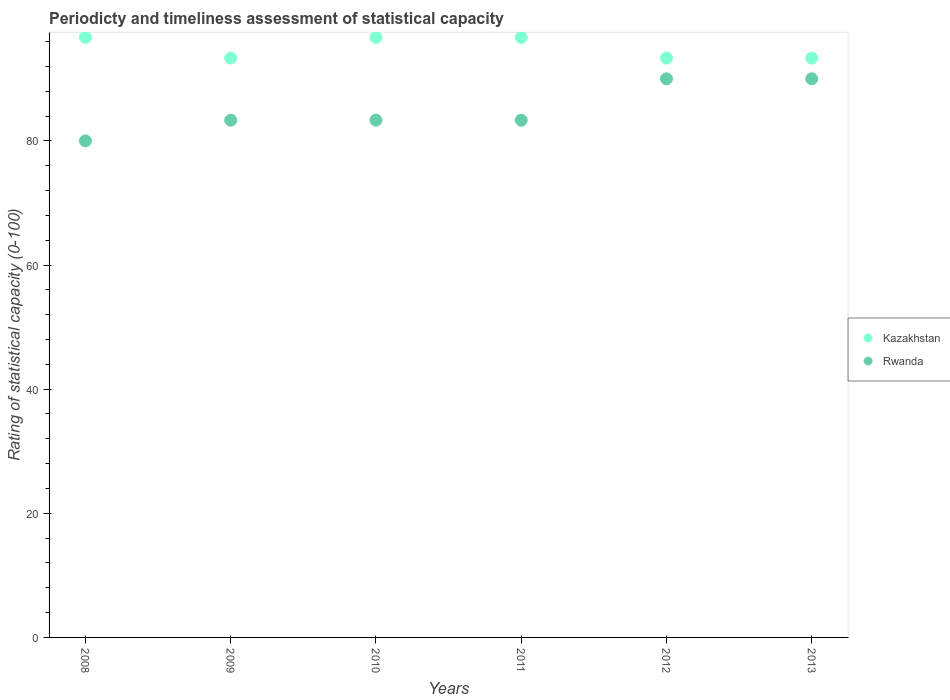What is the rating of statistical capacity in Kazakhstan in 2012?
Your response must be concise. 93.33. Across all years, what is the maximum rating of statistical capacity in Rwanda?
Your answer should be very brief. 90. Across all years, what is the minimum rating of statistical capacity in Rwanda?
Give a very brief answer. 80. In which year was the rating of statistical capacity in Kazakhstan maximum?
Your answer should be very brief. 2008. In which year was the rating of statistical capacity in Kazakhstan minimum?
Give a very brief answer. 2009. What is the total rating of statistical capacity in Rwanda in the graph?
Give a very brief answer. 510. What is the difference between the rating of statistical capacity in Kazakhstan in 2010 and that in 2011?
Provide a short and direct response. 0. What is the difference between the rating of statistical capacity in Kazakhstan in 2013 and the rating of statistical capacity in Rwanda in 2009?
Provide a succinct answer. 10. What is the average rating of statistical capacity in Kazakhstan per year?
Provide a succinct answer. 95. In the year 2010, what is the difference between the rating of statistical capacity in Kazakhstan and rating of statistical capacity in Rwanda?
Provide a short and direct response. 13.33. Is the rating of statistical capacity in Rwanda in 2010 less than that in 2013?
Give a very brief answer. Yes. Is the difference between the rating of statistical capacity in Kazakhstan in 2008 and 2010 greater than the difference between the rating of statistical capacity in Rwanda in 2008 and 2010?
Keep it short and to the point. Yes. What is the difference between the highest and the second highest rating of statistical capacity in Rwanda?
Your answer should be very brief. 0. What is the difference between the highest and the lowest rating of statistical capacity in Kazakhstan?
Offer a very short reply. 3.33. What is the difference between two consecutive major ticks on the Y-axis?
Your response must be concise. 20. Are the values on the major ticks of Y-axis written in scientific E-notation?
Your answer should be compact. No. Does the graph contain any zero values?
Give a very brief answer. No. How are the legend labels stacked?
Provide a succinct answer. Vertical. What is the title of the graph?
Your response must be concise. Periodicty and timeliness assessment of statistical capacity. Does "Poland" appear as one of the legend labels in the graph?
Keep it short and to the point. No. What is the label or title of the X-axis?
Provide a succinct answer. Years. What is the label or title of the Y-axis?
Keep it short and to the point. Rating of statistical capacity (0-100). What is the Rating of statistical capacity (0-100) in Kazakhstan in 2008?
Offer a very short reply. 96.67. What is the Rating of statistical capacity (0-100) of Rwanda in 2008?
Make the answer very short. 80. What is the Rating of statistical capacity (0-100) in Kazakhstan in 2009?
Your answer should be very brief. 93.33. What is the Rating of statistical capacity (0-100) in Rwanda in 2009?
Your response must be concise. 83.33. What is the Rating of statistical capacity (0-100) of Kazakhstan in 2010?
Offer a terse response. 96.67. What is the Rating of statistical capacity (0-100) of Rwanda in 2010?
Provide a short and direct response. 83.33. What is the Rating of statistical capacity (0-100) of Kazakhstan in 2011?
Offer a very short reply. 96.67. What is the Rating of statistical capacity (0-100) in Rwanda in 2011?
Keep it short and to the point. 83.33. What is the Rating of statistical capacity (0-100) of Kazakhstan in 2012?
Provide a short and direct response. 93.33. What is the Rating of statistical capacity (0-100) of Rwanda in 2012?
Give a very brief answer. 90. What is the Rating of statistical capacity (0-100) in Kazakhstan in 2013?
Keep it short and to the point. 93.33. What is the Rating of statistical capacity (0-100) of Rwanda in 2013?
Your response must be concise. 90. Across all years, what is the maximum Rating of statistical capacity (0-100) of Kazakhstan?
Ensure brevity in your answer.  96.67. Across all years, what is the minimum Rating of statistical capacity (0-100) of Kazakhstan?
Offer a terse response. 93.33. Across all years, what is the minimum Rating of statistical capacity (0-100) in Rwanda?
Your answer should be very brief. 80. What is the total Rating of statistical capacity (0-100) of Kazakhstan in the graph?
Ensure brevity in your answer.  570. What is the total Rating of statistical capacity (0-100) in Rwanda in the graph?
Make the answer very short. 510. What is the difference between the Rating of statistical capacity (0-100) of Kazakhstan in 2008 and that in 2010?
Ensure brevity in your answer.  0. What is the difference between the Rating of statistical capacity (0-100) in Rwanda in 2008 and that in 2010?
Keep it short and to the point. -3.33. What is the difference between the Rating of statistical capacity (0-100) of Kazakhstan in 2008 and that in 2011?
Keep it short and to the point. 0. What is the difference between the Rating of statistical capacity (0-100) in Rwanda in 2008 and that in 2011?
Give a very brief answer. -3.33. What is the difference between the Rating of statistical capacity (0-100) in Kazakhstan in 2008 and that in 2012?
Make the answer very short. 3.33. What is the difference between the Rating of statistical capacity (0-100) of Rwanda in 2008 and that in 2012?
Your answer should be compact. -10. What is the difference between the Rating of statistical capacity (0-100) of Rwanda in 2008 and that in 2013?
Keep it short and to the point. -10. What is the difference between the Rating of statistical capacity (0-100) of Kazakhstan in 2009 and that in 2010?
Keep it short and to the point. -3.33. What is the difference between the Rating of statistical capacity (0-100) of Rwanda in 2009 and that in 2012?
Offer a very short reply. -6.67. What is the difference between the Rating of statistical capacity (0-100) in Rwanda in 2009 and that in 2013?
Provide a succinct answer. -6.67. What is the difference between the Rating of statistical capacity (0-100) in Kazakhstan in 2010 and that in 2011?
Provide a short and direct response. 0. What is the difference between the Rating of statistical capacity (0-100) in Rwanda in 2010 and that in 2011?
Your response must be concise. 0. What is the difference between the Rating of statistical capacity (0-100) in Rwanda in 2010 and that in 2012?
Keep it short and to the point. -6.67. What is the difference between the Rating of statistical capacity (0-100) of Kazakhstan in 2010 and that in 2013?
Offer a terse response. 3.33. What is the difference between the Rating of statistical capacity (0-100) in Rwanda in 2010 and that in 2013?
Give a very brief answer. -6.67. What is the difference between the Rating of statistical capacity (0-100) of Rwanda in 2011 and that in 2012?
Offer a very short reply. -6.67. What is the difference between the Rating of statistical capacity (0-100) in Kazakhstan in 2011 and that in 2013?
Provide a short and direct response. 3.33. What is the difference between the Rating of statistical capacity (0-100) of Rwanda in 2011 and that in 2013?
Ensure brevity in your answer.  -6.67. What is the difference between the Rating of statistical capacity (0-100) in Kazakhstan in 2012 and that in 2013?
Give a very brief answer. -0. What is the difference between the Rating of statistical capacity (0-100) in Kazakhstan in 2008 and the Rating of statistical capacity (0-100) in Rwanda in 2009?
Your answer should be compact. 13.33. What is the difference between the Rating of statistical capacity (0-100) of Kazakhstan in 2008 and the Rating of statistical capacity (0-100) of Rwanda in 2010?
Offer a very short reply. 13.33. What is the difference between the Rating of statistical capacity (0-100) of Kazakhstan in 2008 and the Rating of statistical capacity (0-100) of Rwanda in 2011?
Your response must be concise. 13.33. What is the difference between the Rating of statistical capacity (0-100) in Kazakhstan in 2009 and the Rating of statistical capacity (0-100) in Rwanda in 2010?
Offer a terse response. 10. What is the difference between the Rating of statistical capacity (0-100) of Kazakhstan in 2009 and the Rating of statistical capacity (0-100) of Rwanda in 2011?
Provide a succinct answer. 10. What is the difference between the Rating of statistical capacity (0-100) in Kazakhstan in 2010 and the Rating of statistical capacity (0-100) in Rwanda in 2011?
Your response must be concise. 13.33. What is the difference between the Rating of statistical capacity (0-100) in Kazakhstan in 2011 and the Rating of statistical capacity (0-100) in Rwanda in 2013?
Offer a terse response. 6.67. What is the difference between the Rating of statistical capacity (0-100) of Kazakhstan in 2012 and the Rating of statistical capacity (0-100) of Rwanda in 2013?
Make the answer very short. 3.33. What is the average Rating of statistical capacity (0-100) of Kazakhstan per year?
Your answer should be compact. 95. In the year 2008, what is the difference between the Rating of statistical capacity (0-100) in Kazakhstan and Rating of statistical capacity (0-100) in Rwanda?
Offer a very short reply. 16.67. In the year 2009, what is the difference between the Rating of statistical capacity (0-100) of Kazakhstan and Rating of statistical capacity (0-100) of Rwanda?
Give a very brief answer. 10. In the year 2010, what is the difference between the Rating of statistical capacity (0-100) of Kazakhstan and Rating of statistical capacity (0-100) of Rwanda?
Your answer should be very brief. 13.33. In the year 2011, what is the difference between the Rating of statistical capacity (0-100) of Kazakhstan and Rating of statistical capacity (0-100) of Rwanda?
Your response must be concise. 13.33. What is the ratio of the Rating of statistical capacity (0-100) in Kazakhstan in 2008 to that in 2009?
Provide a short and direct response. 1.04. What is the ratio of the Rating of statistical capacity (0-100) of Rwanda in 2008 to that in 2009?
Your answer should be very brief. 0.96. What is the ratio of the Rating of statistical capacity (0-100) in Rwanda in 2008 to that in 2010?
Give a very brief answer. 0.96. What is the ratio of the Rating of statistical capacity (0-100) in Rwanda in 2008 to that in 2011?
Provide a succinct answer. 0.96. What is the ratio of the Rating of statistical capacity (0-100) of Kazakhstan in 2008 to that in 2012?
Your answer should be very brief. 1.04. What is the ratio of the Rating of statistical capacity (0-100) of Rwanda in 2008 to that in 2012?
Provide a short and direct response. 0.89. What is the ratio of the Rating of statistical capacity (0-100) in Kazakhstan in 2008 to that in 2013?
Keep it short and to the point. 1.04. What is the ratio of the Rating of statistical capacity (0-100) in Rwanda in 2008 to that in 2013?
Provide a succinct answer. 0.89. What is the ratio of the Rating of statistical capacity (0-100) in Kazakhstan in 2009 to that in 2010?
Offer a terse response. 0.97. What is the ratio of the Rating of statistical capacity (0-100) of Rwanda in 2009 to that in 2010?
Offer a very short reply. 1. What is the ratio of the Rating of statistical capacity (0-100) in Kazakhstan in 2009 to that in 2011?
Your response must be concise. 0.97. What is the ratio of the Rating of statistical capacity (0-100) in Rwanda in 2009 to that in 2012?
Ensure brevity in your answer.  0.93. What is the ratio of the Rating of statistical capacity (0-100) of Kazakhstan in 2009 to that in 2013?
Ensure brevity in your answer.  1. What is the ratio of the Rating of statistical capacity (0-100) in Rwanda in 2009 to that in 2013?
Your answer should be very brief. 0.93. What is the ratio of the Rating of statistical capacity (0-100) in Kazakhstan in 2010 to that in 2011?
Offer a very short reply. 1. What is the ratio of the Rating of statistical capacity (0-100) of Kazakhstan in 2010 to that in 2012?
Offer a very short reply. 1.04. What is the ratio of the Rating of statistical capacity (0-100) in Rwanda in 2010 to that in 2012?
Offer a very short reply. 0.93. What is the ratio of the Rating of statistical capacity (0-100) of Kazakhstan in 2010 to that in 2013?
Ensure brevity in your answer.  1.04. What is the ratio of the Rating of statistical capacity (0-100) of Rwanda in 2010 to that in 2013?
Your answer should be very brief. 0.93. What is the ratio of the Rating of statistical capacity (0-100) of Kazakhstan in 2011 to that in 2012?
Your answer should be compact. 1.04. What is the ratio of the Rating of statistical capacity (0-100) of Rwanda in 2011 to that in 2012?
Give a very brief answer. 0.93. What is the ratio of the Rating of statistical capacity (0-100) of Kazakhstan in 2011 to that in 2013?
Keep it short and to the point. 1.04. What is the ratio of the Rating of statistical capacity (0-100) of Rwanda in 2011 to that in 2013?
Provide a succinct answer. 0.93. What is the difference between the highest and the second highest Rating of statistical capacity (0-100) of Rwanda?
Your response must be concise. 0. What is the difference between the highest and the lowest Rating of statistical capacity (0-100) of Kazakhstan?
Make the answer very short. 3.33. 